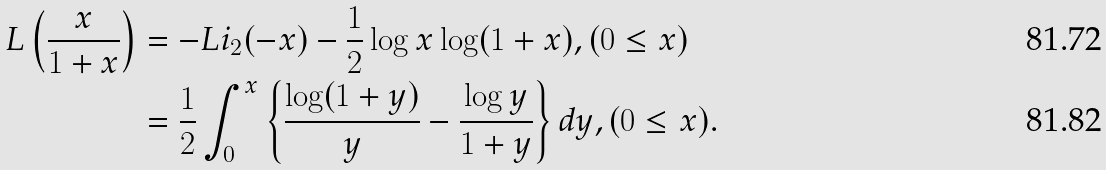<formula> <loc_0><loc_0><loc_500><loc_500>L \left ( \frac { x } { 1 + x } \right ) & = - L i _ { 2 } ( - x ) - \frac { 1 } { 2 } \log x \log ( 1 + x ) , ( 0 \leq x ) \\ & = \frac { 1 } { 2 } \int _ { 0 } ^ { x } \left \{ \frac { \log ( 1 + y ) } { y } - \frac { \log y } { 1 + y } \right \} d y , ( 0 \leq x ) .</formula> 